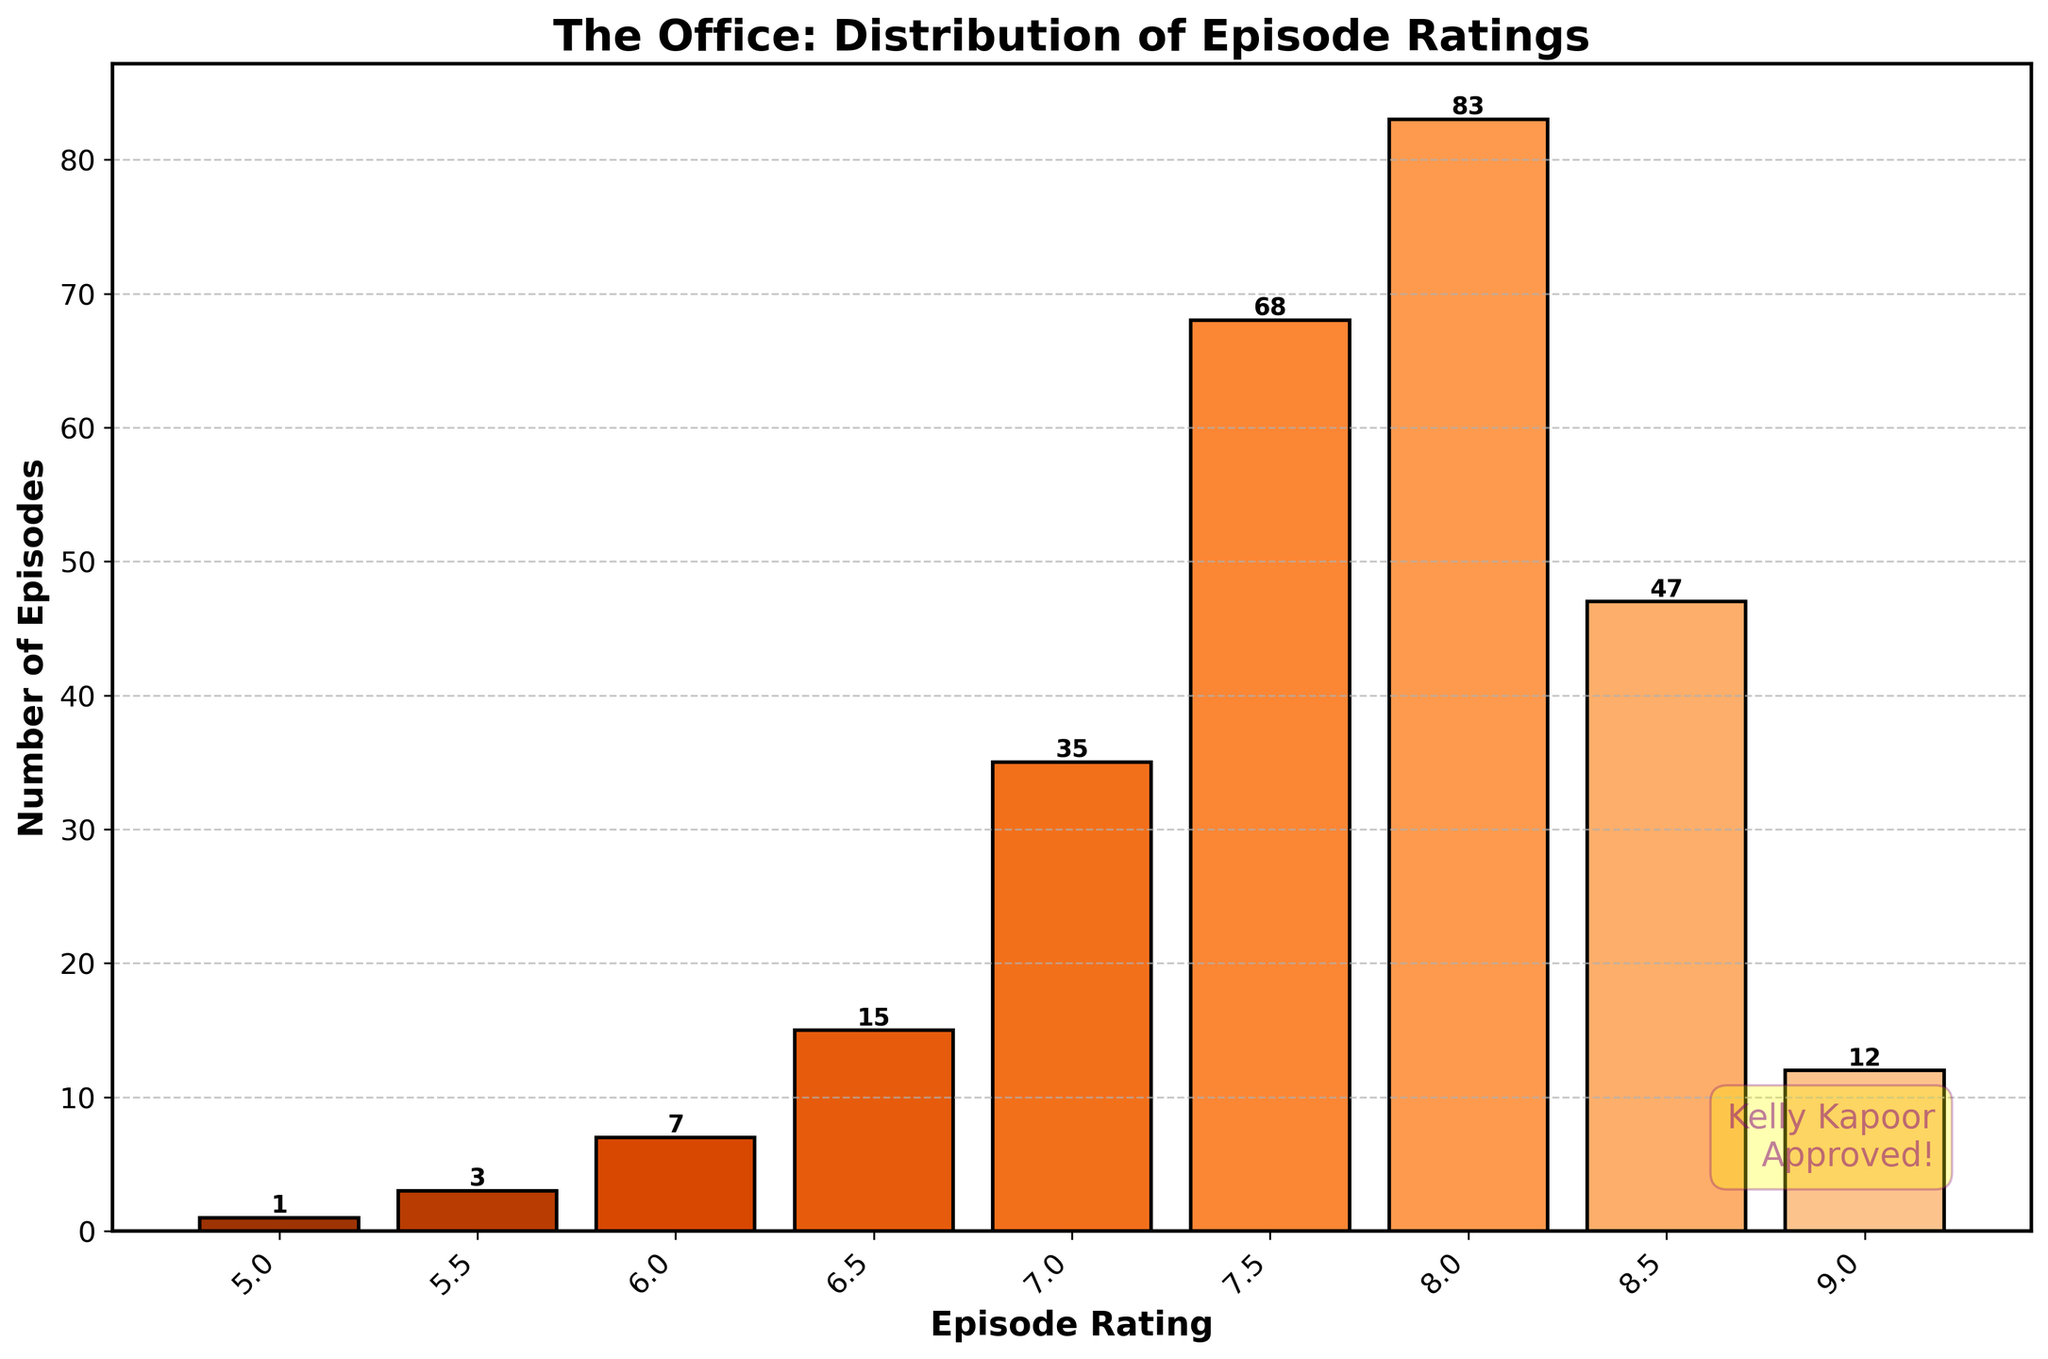What's the title of the figure? The title is usually found at the top of the figure and provides a brief description of what the figure is about. The title of this histogram indicates what is being depicted.
Answer: The Office: Distribution of Episode Ratings What is the range of episodes rated between 8.0 and 8.4? Look for the bar labeled between 8.0 and 8.4 on the x-axis and check the height of the bar or the number at the top of the bar to determine the number of episodes.
Answer: 83 Which rating range has the highest frequency of episodes? You need to find the tallest bar in the histogram and check the label on the x-axis. The tallest bar represents the rating range with the most episodes.
Answer: 8.0-8.4 How many episodes have a rating of at least 9.0? Look at the bar for the rating range 9.0-9.5 on the x-axis and check the height value or the number at the top of the bar to see how many episodes are in this range.
Answer: 12 How many ratings are below 6.5? Sum the frequencies of all bars with a rating below 6.5. Add the frequencies for rating ranges 6.0-6.4, 5.5-5.9, and 5.0-5.4.
Answer: 7 + 3 + 1 = 11 How do the number of episodes rated between 7.5-7.9 compare to those rated between 6.5-6.9? Compare the heights or the numbers at the top of the bars for the ranges 7.5-7.9 and 6.5-6.9 to see which is larger.
Answer: 68 is greater than 15 Which range has more episodes rated: 8.5-8.9 or 7.5-7.9? Compare the height values or the numbers at the top of the bars for the ranges 8.5-8.9 and 7.5-7.9 to see which range has more episodes.
Answer: 8.5-8.9 What is the total number of episodes rated between 7.0 and 9.5? Sum the frequencies of the rating ranges from 7.0 to 9.5. Add the frequencies for the ranges 9.0-9.5, 8.5-8.9, 8.0-8.4, 7.5-7.9, and 7.0-7.4.
Answer: 12 + 47 + 83 + 68 + 35 = 245 What value is the mode of this distribution? The mode is the value that appears most frequently. In a histogram, it corresponds to the rating range with the highest bar.
Answer: 8.0-8.4 